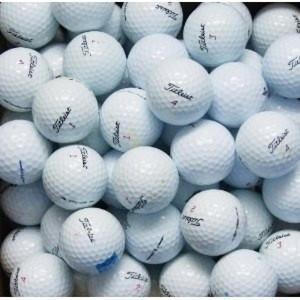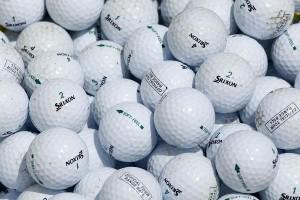The first image is the image on the left, the second image is the image on the right. Examine the images to the left and right. Is the description "Some of the golf balls are off white due to dirt." accurate? Answer yes or no. No. The first image is the image on the left, the second image is the image on the right. For the images displayed, is the sentence "One of the images includes dirty, used golf balls." factually correct? Answer yes or no. No. The first image is the image on the left, the second image is the image on the right. Evaluate the accuracy of this statement regarding the images: "The golfballs in one photo appear dirty from use.". Is it true? Answer yes or no. No. The first image is the image on the left, the second image is the image on the right. Considering the images on both sides, is "One image shows only cleaned golf balls and the other image includes dirty golf balls." valid? Answer yes or no. No. 